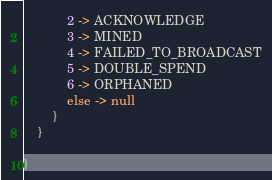<code> <loc_0><loc_0><loc_500><loc_500><_Kotlin_>            2 -> ACKNOWLEDGE
            3 -> MINED
            4 -> FAILED_TO_BROADCAST
            5 -> DOUBLE_SPEND
            6 -> ORPHANED
            else -> null
        }
    }

}
</code> 